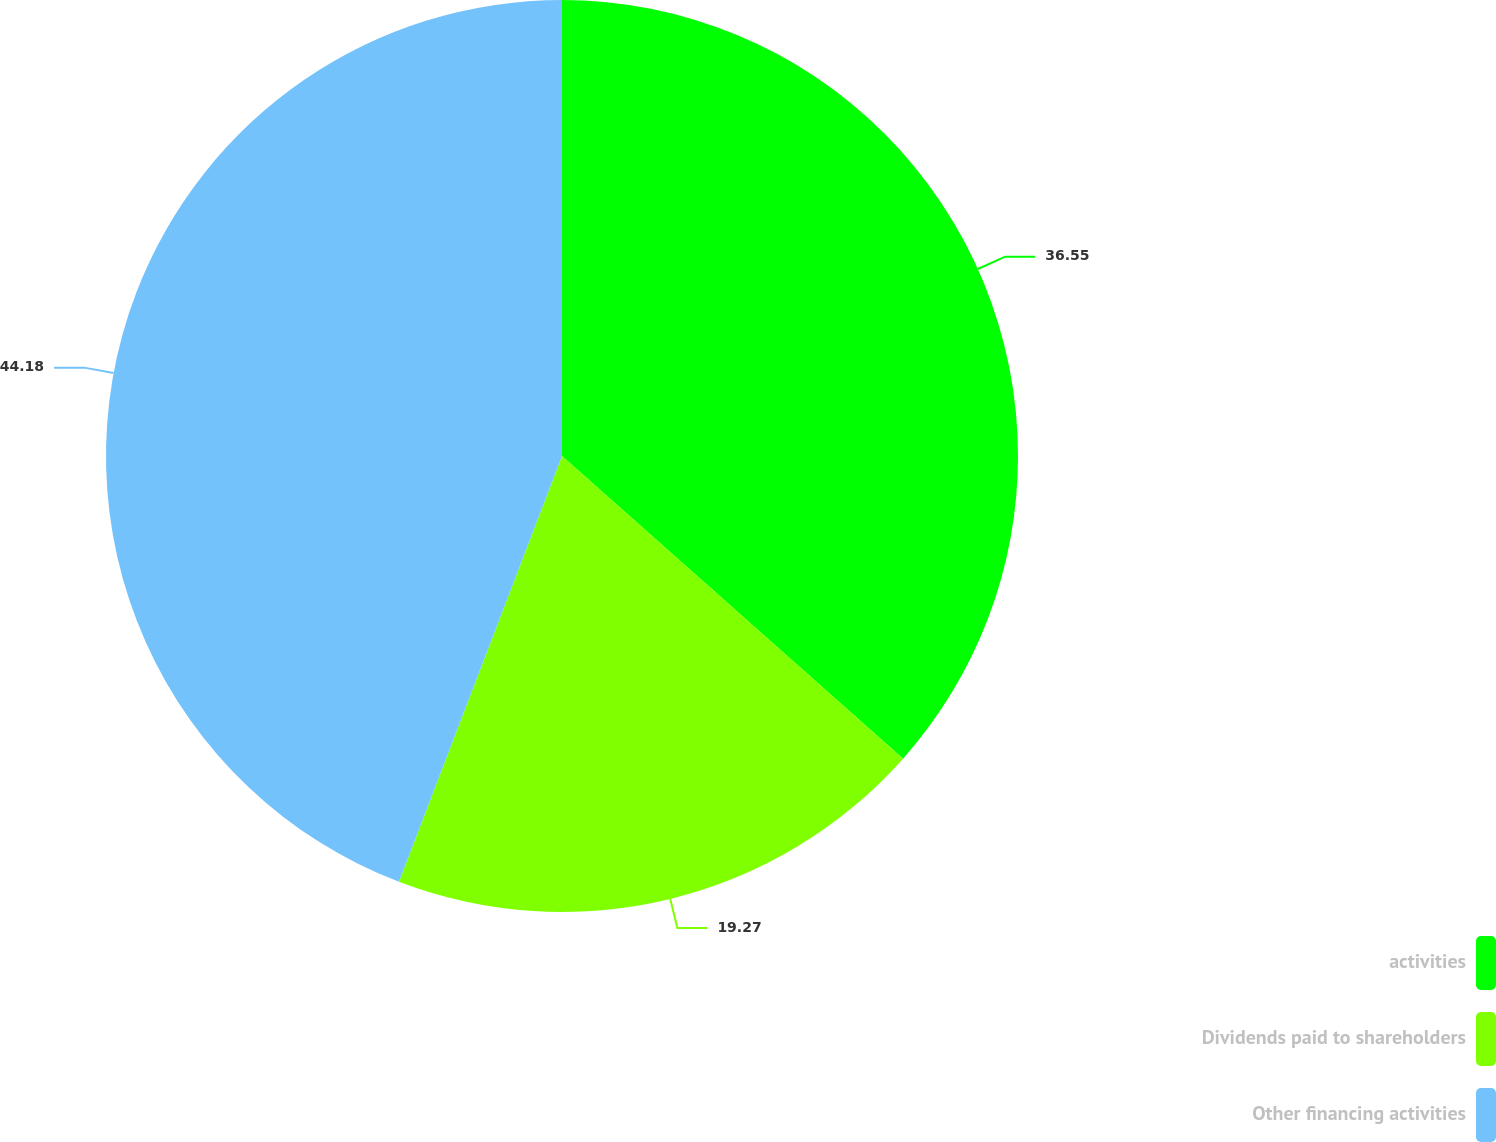Convert chart to OTSL. <chart><loc_0><loc_0><loc_500><loc_500><pie_chart><fcel>activities<fcel>Dividends paid to shareholders<fcel>Other financing activities<nl><fcel>36.55%<fcel>19.27%<fcel>44.18%<nl></chart> 